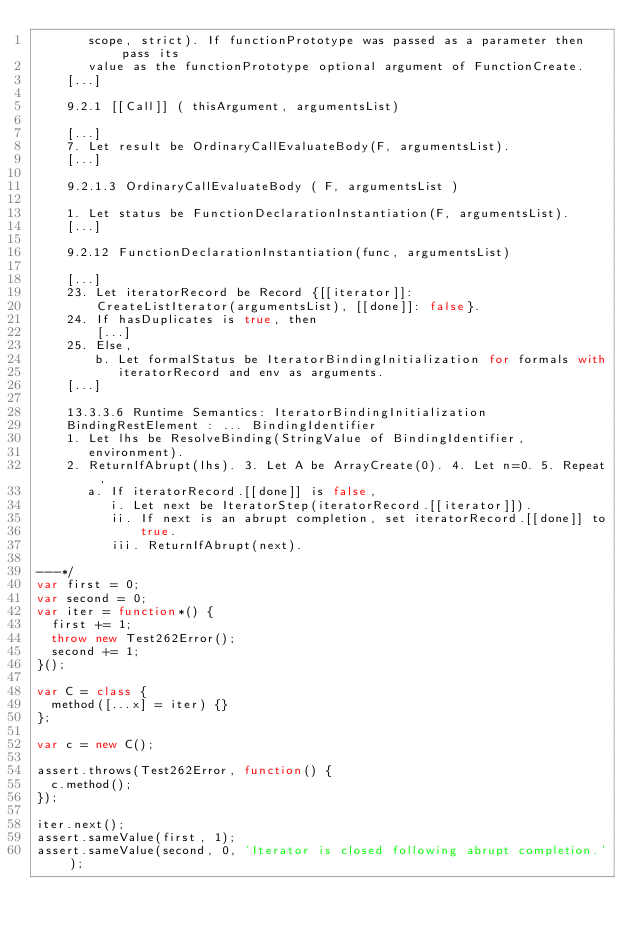Convert code to text. <code><loc_0><loc_0><loc_500><loc_500><_JavaScript_>       scope, strict). If functionPrototype was passed as a parameter then pass its
       value as the functionPrototype optional argument of FunctionCreate.
    [...]

    9.2.1 [[Call]] ( thisArgument, argumentsList)

    [...]
    7. Let result be OrdinaryCallEvaluateBody(F, argumentsList).
    [...]

    9.2.1.3 OrdinaryCallEvaluateBody ( F, argumentsList )

    1. Let status be FunctionDeclarationInstantiation(F, argumentsList).
    [...]

    9.2.12 FunctionDeclarationInstantiation(func, argumentsList)

    [...]
    23. Let iteratorRecord be Record {[[iterator]]:
        CreateListIterator(argumentsList), [[done]]: false}.
    24. If hasDuplicates is true, then
        [...]
    25. Else,
        b. Let formalStatus be IteratorBindingInitialization for formals with
           iteratorRecord and env as arguments.
    [...]

    13.3.3.6 Runtime Semantics: IteratorBindingInitialization
    BindingRestElement : ... BindingIdentifier
    1. Let lhs be ResolveBinding(StringValue of BindingIdentifier,
       environment).
    2. ReturnIfAbrupt(lhs). 3. Let A be ArrayCreate(0). 4. Let n=0. 5. Repeat,
       a. If iteratorRecord.[[done]] is false,
          i. Let next be IteratorStep(iteratorRecord.[[iterator]]).
          ii. If next is an abrupt completion, set iteratorRecord.[[done]] to
              true.
          iii. ReturnIfAbrupt(next).

---*/
var first = 0;
var second = 0;
var iter = function*() {
  first += 1;
  throw new Test262Error();
  second += 1;
}();

var C = class {
  method([...x] = iter) {}
};

var c = new C();

assert.throws(Test262Error, function() {
  c.method();
});

iter.next();
assert.sameValue(first, 1);
assert.sameValue(second, 0, 'Iterator is closed following abrupt completion.');
</code> 